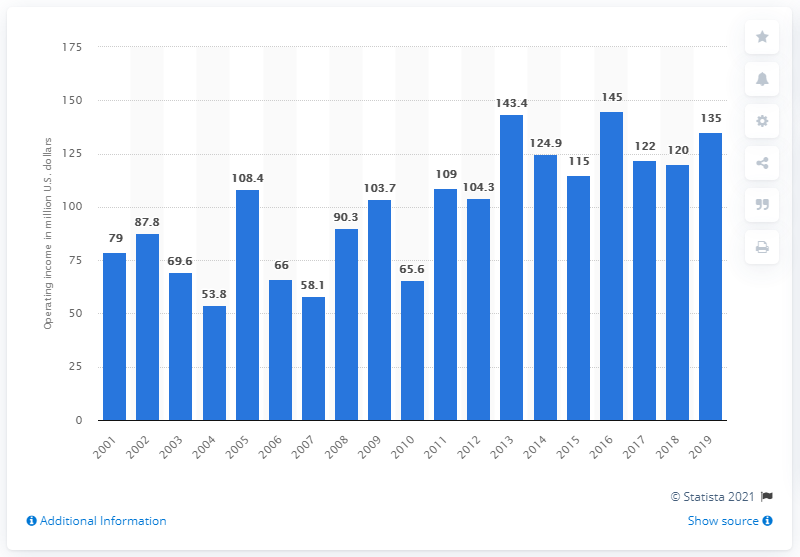Mention a couple of crucial points in this snapshot. The operating income of the Washington Football Team during the 2019 season was 135. 